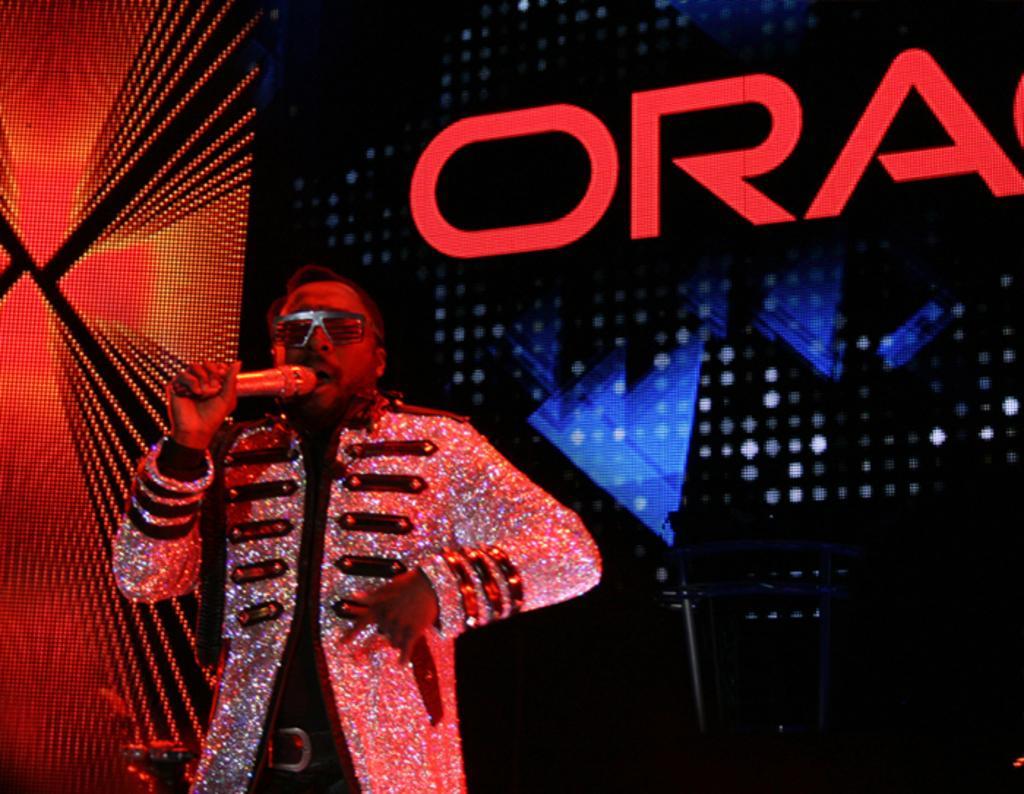Can you describe this image briefly? In this image we can see a person wearing a costume. A person is speaking into a microphone. There is a digital screen in the image. There is some text on the screen. 